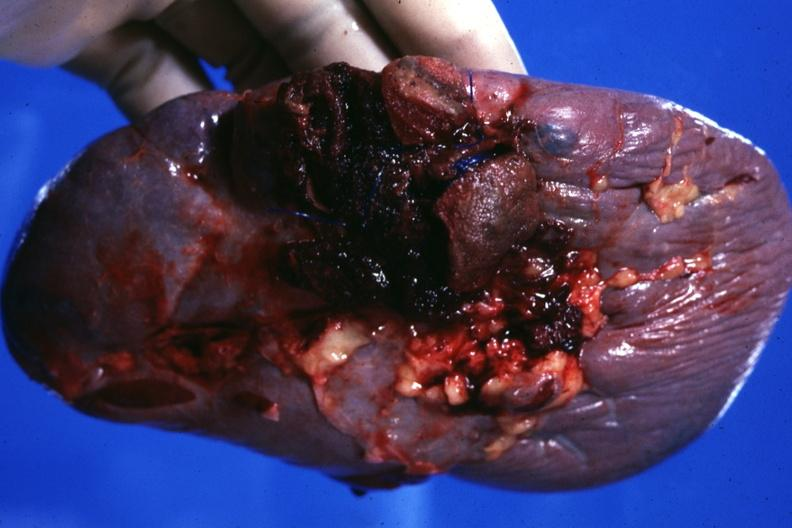where is this part in?
Answer the question using a single word or phrase. Spleen 